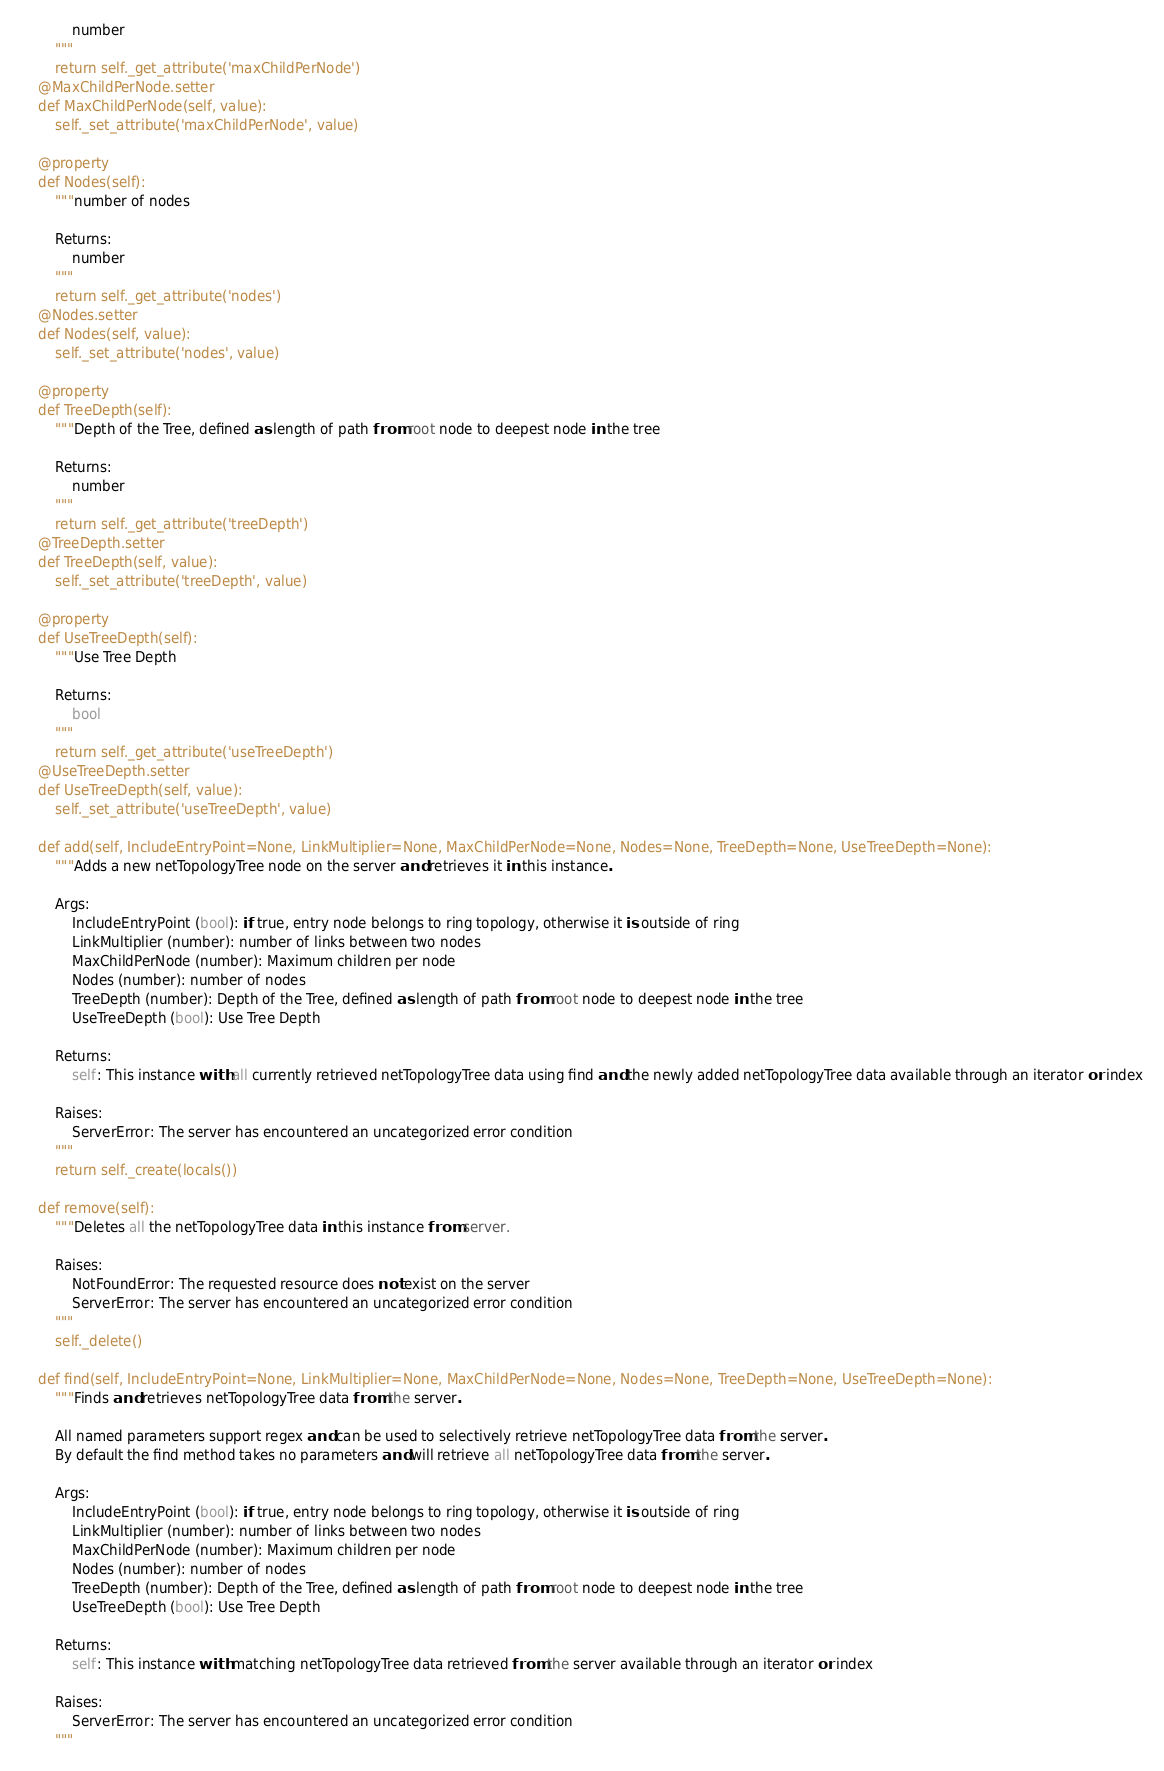<code> <loc_0><loc_0><loc_500><loc_500><_Python_>			number
		"""
		return self._get_attribute('maxChildPerNode')
	@MaxChildPerNode.setter
	def MaxChildPerNode(self, value):
		self._set_attribute('maxChildPerNode', value)

	@property
	def Nodes(self):
		"""number of nodes

		Returns:
			number
		"""
		return self._get_attribute('nodes')
	@Nodes.setter
	def Nodes(self, value):
		self._set_attribute('nodes', value)

	@property
	def TreeDepth(self):
		"""Depth of the Tree, defined as length of path from root node to deepest node in the tree

		Returns:
			number
		"""
		return self._get_attribute('treeDepth')
	@TreeDepth.setter
	def TreeDepth(self, value):
		self._set_attribute('treeDepth', value)

	@property
	def UseTreeDepth(self):
		"""Use Tree Depth

		Returns:
			bool
		"""
		return self._get_attribute('useTreeDepth')
	@UseTreeDepth.setter
	def UseTreeDepth(self, value):
		self._set_attribute('useTreeDepth', value)

	def add(self, IncludeEntryPoint=None, LinkMultiplier=None, MaxChildPerNode=None, Nodes=None, TreeDepth=None, UseTreeDepth=None):
		"""Adds a new netTopologyTree node on the server and retrieves it in this instance.

		Args:
			IncludeEntryPoint (bool): if true, entry node belongs to ring topology, otherwise it is outside of ring
			LinkMultiplier (number): number of links between two nodes
			MaxChildPerNode (number): Maximum children per node
			Nodes (number): number of nodes
			TreeDepth (number): Depth of the Tree, defined as length of path from root node to deepest node in the tree
			UseTreeDepth (bool): Use Tree Depth

		Returns:
			self: This instance with all currently retrieved netTopologyTree data using find and the newly added netTopologyTree data available through an iterator or index

		Raises:
			ServerError: The server has encountered an uncategorized error condition
		"""
		return self._create(locals())

	def remove(self):
		"""Deletes all the netTopologyTree data in this instance from server.

		Raises:
			NotFoundError: The requested resource does not exist on the server
			ServerError: The server has encountered an uncategorized error condition
		"""
		self._delete()

	def find(self, IncludeEntryPoint=None, LinkMultiplier=None, MaxChildPerNode=None, Nodes=None, TreeDepth=None, UseTreeDepth=None):
		"""Finds and retrieves netTopologyTree data from the server.

		All named parameters support regex and can be used to selectively retrieve netTopologyTree data from the server.
		By default the find method takes no parameters and will retrieve all netTopologyTree data from the server.

		Args:
			IncludeEntryPoint (bool): if true, entry node belongs to ring topology, otherwise it is outside of ring
			LinkMultiplier (number): number of links between two nodes
			MaxChildPerNode (number): Maximum children per node
			Nodes (number): number of nodes
			TreeDepth (number): Depth of the Tree, defined as length of path from root node to deepest node in the tree
			UseTreeDepth (bool): Use Tree Depth

		Returns:
			self: This instance with matching netTopologyTree data retrieved from the server available through an iterator or index

		Raises:
			ServerError: The server has encountered an uncategorized error condition
		"""</code> 